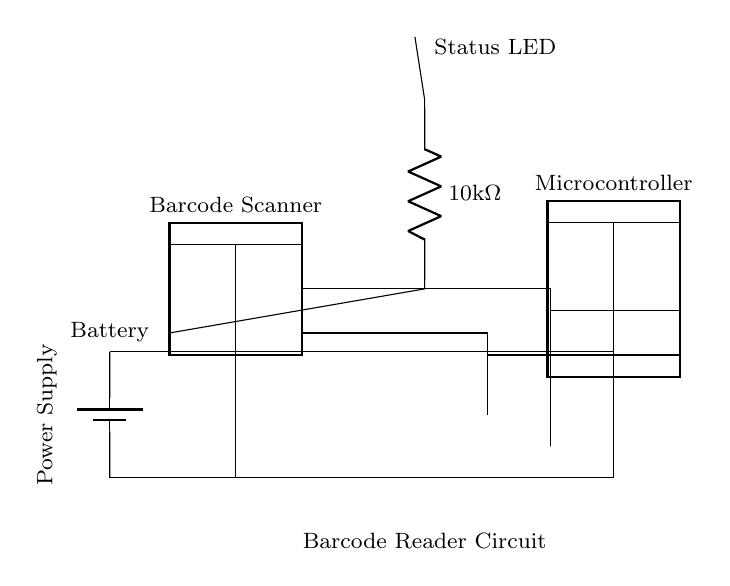What is the main component of this circuit? The main component is the barcode scanner, indicated by the dipchip symbol at the left. This is the primary device responsible for scanning barcodes in the order processing system.
Answer: barcode scanner How many pins does the microcontroller have? The microcontroller is represented by a dipchip with 8 pins, which can be inferred from the depiction in the diagram. The number of pins is a characteristic feature of the component's design.
Answer: 8 pins What is the resistance value of the resistor in the circuit? The circuit includes a resistor labeled with a value of 10k ohms, shown clearly next to the resistor symbol. This specific value is critical for the functioning of the circuit, especially for current control.
Answer: 10k ohm What component indicates the status of the circuit? The status LED serves as an indicator for the circuit's operational state, positioned at the top center of the diagram, signifying activity or readiness in the system.
Answer: status LED Which component supplies power to the circuit? The battery is the power supply component, located at the left bottom of the circuit, connected to both the barcode scanner and microcontroller, providing the necessary voltage and current for operation.
Answer: battery What type of circuit is this diagram representing? This diagram represents a barcode reader circuit, which is specifically designed for efficient order processing by scanning barcodes, as indicated by the overall arrangement and components included in the design.
Answer: barcode reader circuit How does the barcode scanner connect to the microcontroller? The barcode scanner connects to the microcontroller through two connections marked by pins; pin 4 from the scanner goes to pin 5 of the microcontroller, and pin 5 to pin 6, facilitating data transmission.
Answer: two connections 